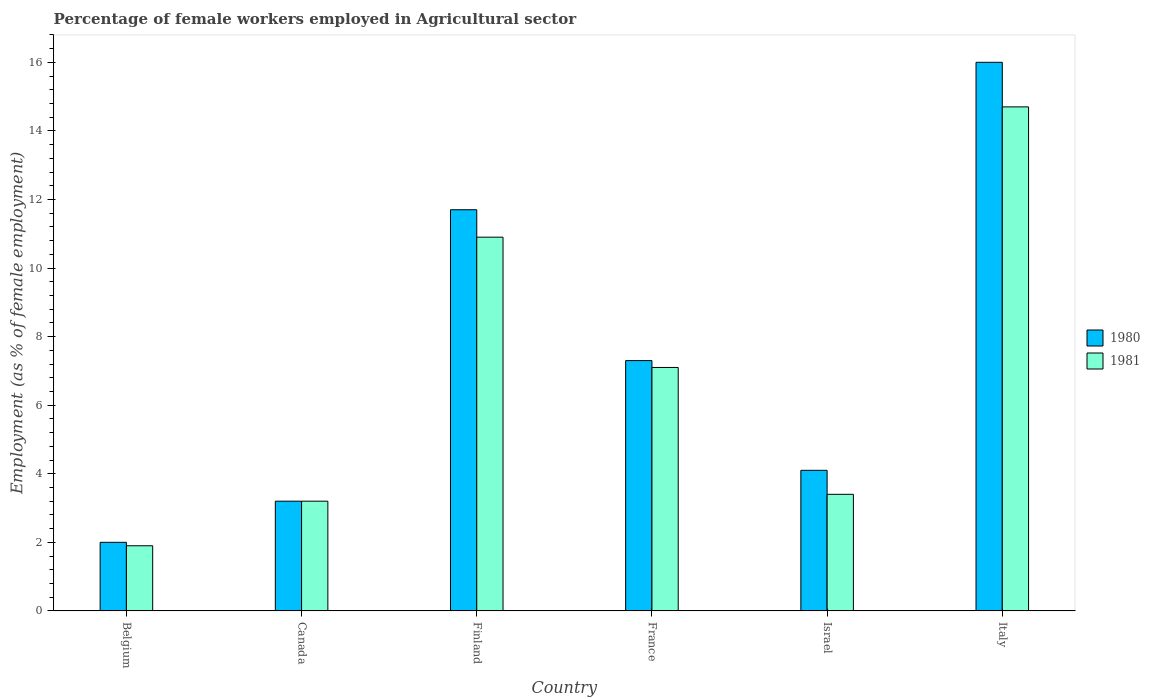How many different coloured bars are there?
Your answer should be very brief. 2. Are the number of bars on each tick of the X-axis equal?
Your answer should be compact. Yes. How many bars are there on the 4th tick from the left?
Make the answer very short. 2. How many bars are there on the 2nd tick from the right?
Provide a succinct answer. 2. What is the label of the 3rd group of bars from the left?
Make the answer very short. Finland. What is the percentage of females employed in Agricultural sector in 1980 in Belgium?
Your answer should be compact. 2. Across all countries, what is the maximum percentage of females employed in Agricultural sector in 1981?
Give a very brief answer. 14.7. Across all countries, what is the minimum percentage of females employed in Agricultural sector in 1981?
Your response must be concise. 1.9. In which country was the percentage of females employed in Agricultural sector in 1980 maximum?
Offer a very short reply. Italy. In which country was the percentage of females employed in Agricultural sector in 1981 minimum?
Ensure brevity in your answer.  Belgium. What is the total percentage of females employed in Agricultural sector in 1981 in the graph?
Your answer should be very brief. 41.2. What is the difference between the percentage of females employed in Agricultural sector in 1981 in Belgium and that in Finland?
Your answer should be very brief. -9. What is the difference between the percentage of females employed in Agricultural sector in 1980 in France and the percentage of females employed in Agricultural sector in 1981 in Italy?
Your answer should be very brief. -7.4. What is the average percentage of females employed in Agricultural sector in 1981 per country?
Keep it short and to the point. 6.87. What is the difference between the percentage of females employed in Agricultural sector of/in 1980 and percentage of females employed in Agricultural sector of/in 1981 in Canada?
Give a very brief answer. 0. What is the ratio of the percentage of females employed in Agricultural sector in 1980 in France to that in Italy?
Ensure brevity in your answer.  0.46. Is the percentage of females employed in Agricultural sector in 1981 in Canada less than that in Italy?
Provide a succinct answer. Yes. What is the difference between the highest and the second highest percentage of females employed in Agricultural sector in 1981?
Provide a succinct answer. -3.8. What is the difference between the highest and the lowest percentage of females employed in Agricultural sector in 1980?
Provide a succinct answer. 14. In how many countries, is the percentage of females employed in Agricultural sector in 1980 greater than the average percentage of females employed in Agricultural sector in 1980 taken over all countries?
Provide a short and direct response. 2. How many bars are there?
Provide a succinct answer. 12. Are all the bars in the graph horizontal?
Make the answer very short. No. How many countries are there in the graph?
Offer a terse response. 6. Does the graph contain any zero values?
Provide a succinct answer. No. Does the graph contain grids?
Provide a short and direct response. No. Where does the legend appear in the graph?
Give a very brief answer. Center right. What is the title of the graph?
Give a very brief answer. Percentage of female workers employed in Agricultural sector. Does "1999" appear as one of the legend labels in the graph?
Provide a succinct answer. No. What is the label or title of the X-axis?
Offer a very short reply. Country. What is the label or title of the Y-axis?
Offer a very short reply. Employment (as % of female employment). What is the Employment (as % of female employment) of 1981 in Belgium?
Your answer should be compact. 1.9. What is the Employment (as % of female employment) in 1980 in Canada?
Ensure brevity in your answer.  3.2. What is the Employment (as % of female employment) in 1981 in Canada?
Your answer should be very brief. 3.2. What is the Employment (as % of female employment) of 1980 in Finland?
Your answer should be compact. 11.7. What is the Employment (as % of female employment) in 1981 in Finland?
Offer a very short reply. 10.9. What is the Employment (as % of female employment) of 1980 in France?
Provide a succinct answer. 7.3. What is the Employment (as % of female employment) in 1981 in France?
Offer a very short reply. 7.1. What is the Employment (as % of female employment) of 1980 in Israel?
Your answer should be compact. 4.1. What is the Employment (as % of female employment) of 1981 in Israel?
Ensure brevity in your answer.  3.4. What is the Employment (as % of female employment) of 1981 in Italy?
Keep it short and to the point. 14.7. Across all countries, what is the maximum Employment (as % of female employment) of 1981?
Provide a short and direct response. 14.7. Across all countries, what is the minimum Employment (as % of female employment) of 1981?
Offer a terse response. 1.9. What is the total Employment (as % of female employment) of 1980 in the graph?
Your response must be concise. 44.3. What is the total Employment (as % of female employment) of 1981 in the graph?
Provide a succinct answer. 41.2. What is the difference between the Employment (as % of female employment) of 1980 in Belgium and that in Finland?
Make the answer very short. -9.7. What is the difference between the Employment (as % of female employment) of 1981 in Belgium and that in France?
Your answer should be very brief. -5.2. What is the difference between the Employment (as % of female employment) in 1981 in Belgium and that in Italy?
Give a very brief answer. -12.8. What is the difference between the Employment (as % of female employment) in 1980 in Canada and that in Finland?
Provide a succinct answer. -8.5. What is the difference between the Employment (as % of female employment) of 1980 in Canada and that in France?
Provide a short and direct response. -4.1. What is the difference between the Employment (as % of female employment) in 1981 in Canada and that in France?
Provide a succinct answer. -3.9. What is the difference between the Employment (as % of female employment) of 1980 in Canada and that in Israel?
Your answer should be compact. -0.9. What is the difference between the Employment (as % of female employment) of 1981 in Canada and that in Israel?
Provide a short and direct response. -0.2. What is the difference between the Employment (as % of female employment) in 1980 in Finland and that in France?
Your answer should be compact. 4.4. What is the difference between the Employment (as % of female employment) of 1981 in Finland and that in France?
Provide a short and direct response. 3.8. What is the difference between the Employment (as % of female employment) in 1980 in Finland and that in Israel?
Keep it short and to the point. 7.6. What is the difference between the Employment (as % of female employment) in 1980 in Finland and that in Italy?
Ensure brevity in your answer.  -4.3. What is the difference between the Employment (as % of female employment) of 1981 in Finland and that in Italy?
Offer a terse response. -3.8. What is the difference between the Employment (as % of female employment) of 1980 in France and that in Italy?
Offer a very short reply. -8.7. What is the difference between the Employment (as % of female employment) of 1980 in Israel and that in Italy?
Your response must be concise. -11.9. What is the difference between the Employment (as % of female employment) of 1980 in Belgium and the Employment (as % of female employment) of 1981 in Canada?
Offer a terse response. -1.2. What is the difference between the Employment (as % of female employment) in 1980 in Belgium and the Employment (as % of female employment) in 1981 in France?
Provide a succinct answer. -5.1. What is the difference between the Employment (as % of female employment) in 1980 in Canada and the Employment (as % of female employment) in 1981 in Finland?
Your response must be concise. -7.7. What is the difference between the Employment (as % of female employment) in 1980 in Canada and the Employment (as % of female employment) in 1981 in Israel?
Keep it short and to the point. -0.2. What is the difference between the Employment (as % of female employment) in 1980 in Finland and the Employment (as % of female employment) in 1981 in Israel?
Ensure brevity in your answer.  8.3. What is the difference between the Employment (as % of female employment) of 1980 in France and the Employment (as % of female employment) of 1981 in Israel?
Make the answer very short. 3.9. What is the difference between the Employment (as % of female employment) of 1980 in France and the Employment (as % of female employment) of 1981 in Italy?
Provide a succinct answer. -7.4. What is the difference between the Employment (as % of female employment) of 1980 in Israel and the Employment (as % of female employment) of 1981 in Italy?
Offer a terse response. -10.6. What is the average Employment (as % of female employment) of 1980 per country?
Your response must be concise. 7.38. What is the average Employment (as % of female employment) in 1981 per country?
Offer a terse response. 6.87. What is the difference between the Employment (as % of female employment) of 1980 and Employment (as % of female employment) of 1981 in Canada?
Make the answer very short. 0. What is the difference between the Employment (as % of female employment) of 1980 and Employment (as % of female employment) of 1981 in Finland?
Your answer should be very brief. 0.8. What is the difference between the Employment (as % of female employment) in 1980 and Employment (as % of female employment) in 1981 in France?
Give a very brief answer. 0.2. What is the ratio of the Employment (as % of female employment) of 1980 in Belgium to that in Canada?
Keep it short and to the point. 0.62. What is the ratio of the Employment (as % of female employment) of 1981 in Belgium to that in Canada?
Offer a very short reply. 0.59. What is the ratio of the Employment (as % of female employment) in 1980 in Belgium to that in Finland?
Your answer should be very brief. 0.17. What is the ratio of the Employment (as % of female employment) of 1981 in Belgium to that in Finland?
Your answer should be compact. 0.17. What is the ratio of the Employment (as % of female employment) of 1980 in Belgium to that in France?
Your response must be concise. 0.27. What is the ratio of the Employment (as % of female employment) of 1981 in Belgium to that in France?
Provide a short and direct response. 0.27. What is the ratio of the Employment (as % of female employment) of 1980 in Belgium to that in Israel?
Provide a succinct answer. 0.49. What is the ratio of the Employment (as % of female employment) in 1981 in Belgium to that in Israel?
Ensure brevity in your answer.  0.56. What is the ratio of the Employment (as % of female employment) of 1980 in Belgium to that in Italy?
Your response must be concise. 0.12. What is the ratio of the Employment (as % of female employment) in 1981 in Belgium to that in Italy?
Give a very brief answer. 0.13. What is the ratio of the Employment (as % of female employment) of 1980 in Canada to that in Finland?
Keep it short and to the point. 0.27. What is the ratio of the Employment (as % of female employment) in 1981 in Canada to that in Finland?
Keep it short and to the point. 0.29. What is the ratio of the Employment (as % of female employment) of 1980 in Canada to that in France?
Give a very brief answer. 0.44. What is the ratio of the Employment (as % of female employment) of 1981 in Canada to that in France?
Your answer should be very brief. 0.45. What is the ratio of the Employment (as % of female employment) in 1980 in Canada to that in Israel?
Ensure brevity in your answer.  0.78. What is the ratio of the Employment (as % of female employment) of 1981 in Canada to that in Israel?
Offer a very short reply. 0.94. What is the ratio of the Employment (as % of female employment) in 1980 in Canada to that in Italy?
Give a very brief answer. 0.2. What is the ratio of the Employment (as % of female employment) in 1981 in Canada to that in Italy?
Keep it short and to the point. 0.22. What is the ratio of the Employment (as % of female employment) in 1980 in Finland to that in France?
Offer a very short reply. 1.6. What is the ratio of the Employment (as % of female employment) in 1981 in Finland to that in France?
Keep it short and to the point. 1.54. What is the ratio of the Employment (as % of female employment) of 1980 in Finland to that in Israel?
Offer a very short reply. 2.85. What is the ratio of the Employment (as % of female employment) in 1981 in Finland to that in Israel?
Provide a short and direct response. 3.21. What is the ratio of the Employment (as % of female employment) of 1980 in Finland to that in Italy?
Provide a short and direct response. 0.73. What is the ratio of the Employment (as % of female employment) in 1981 in Finland to that in Italy?
Make the answer very short. 0.74. What is the ratio of the Employment (as % of female employment) of 1980 in France to that in Israel?
Provide a short and direct response. 1.78. What is the ratio of the Employment (as % of female employment) of 1981 in France to that in Israel?
Give a very brief answer. 2.09. What is the ratio of the Employment (as % of female employment) in 1980 in France to that in Italy?
Offer a terse response. 0.46. What is the ratio of the Employment (as % of female employment) in 1981 in France to that in Italy?
Provide a short and direct response. 0.48. What is the ratio of the Employment (as % of female employment) in 1980 in Israel to that in Italy?
Make the answer very short. 0.26. What is the ratio of the Employment (as % of female employment) in 1981 in Israel to that in Italy?
Provide a succinct answer. 0.23. What is the difference between the highest and the second highest Employment (as % of female employment) in 1980?
Ensure brevity in your answer.  4.3. What is the difference between the highest and the second highest Employment (as % of female employment) in 1981?
Offer a very short reply. 3.8. What is the difference between the highest and the lowest Employment (as % of female employment) in 1980?
Ensure brevity in your answer.  14. What is the difference between the highest and the lowest Employment (as % of female employment) in 1981?
Make the answer very short. 12.8. 